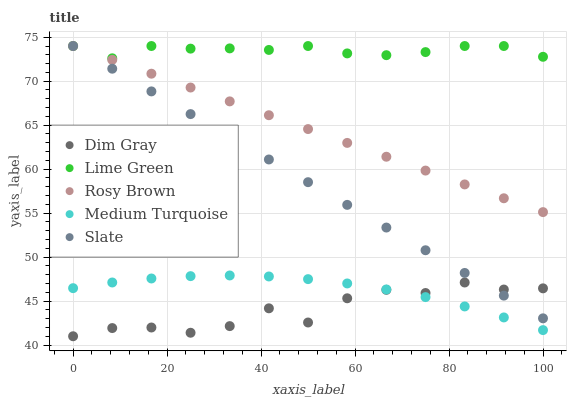Does Dim Gray have the minimum area under the curve?
Answer yes or no. Yes. Does Lime Green have the maximum area under the curve?
Answer yes or no. Yes. Does Lime Green have the minimum area under the curve?
Answer yes or no. No. Does Dim Gray have the maximum area under the curve?
Answer yes or no. No. Is Slate the smoothest?
Answer yes or no. Yes. Is Dim Gray the roughest?
Answer yes or no. Yes. Is Lime Green the smoothest?
Answer yes or no. No. Is Lime Green the roughest?
Answer yes or no. No. Does Dim Gray have the lowest value?
Answer yes or no. Yes. Does Lime Green have the lowest value?
Answer yes or no. No. Does Slate have the highest value?
Answer yes or no. Yes. Does Dim Gray have the highest value?
Answer yes or no. No. Is Medium Turquoise less than Rosy Brown?
Answer yes or no. Yes. Is Lime Green greater than Medium Turquoise?
Answer yes or no. Yes. Does Rosy Brown intersect Slate?
Answer yes or no. Yes. Is Rosy Brown less than Slate?
Answer yes or no. No. Is Rosy Brown greater than Slate?
Answer yes or no. No. Does Medium Turquoise intersect Rosy Brown?
Answer yes or no. No. 